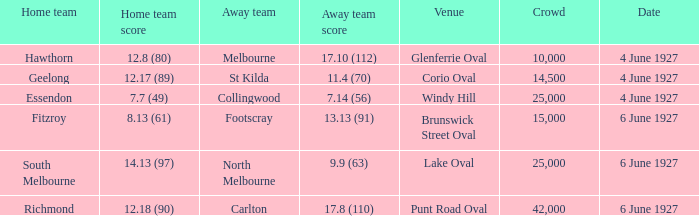How many people in the crowd with north melbourne as an away team? 25000.0. 